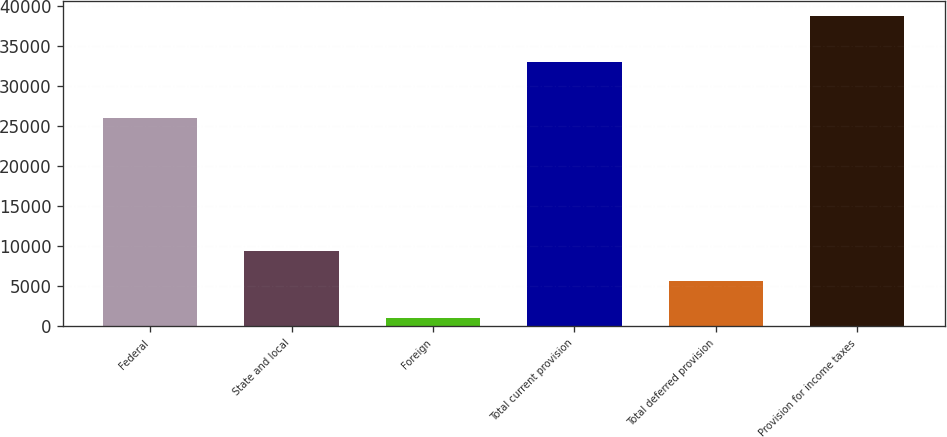<chart> <loc_0><loc_0><loc_500><loc_500><bar_chart><fcel>Federal<fcel>State and local<fcel>Foreign<fcel>Total current provision<fcel>Total deferred provision<fcel>Provision for income taxes<nl><fcel>26071<fcel>9444.3<fcel>1014<fcel>33043<fcel>5674<fcel>38717<nl></chart> 